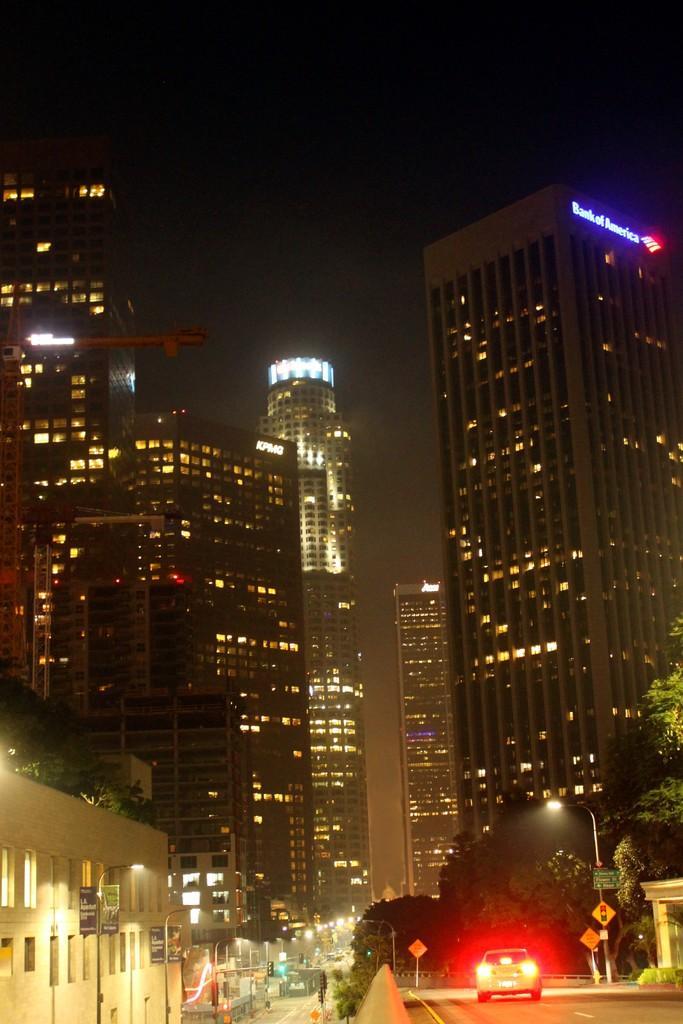Can you describe this image briefly? This image is clicked on the road. In the bottom left there is a car moving on the road. In front of the car there are trees and sign board poles. In the background there are buildings. There are boards with text on the buildings. At the top there is the sky. There are street light poles in the image. 